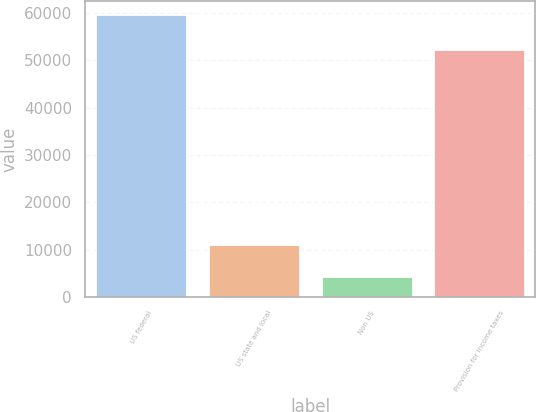Convert chart. <chart><loc_0><loc_0><loc_500><loc_500><bar_chart><fcel>US federal<fcel>US state and local<fcel>Non US<fcel>Provision for income taxes<nl><fcel>59608<fcel>10886<fcel>4261<fcel>52181<nl></chart> 